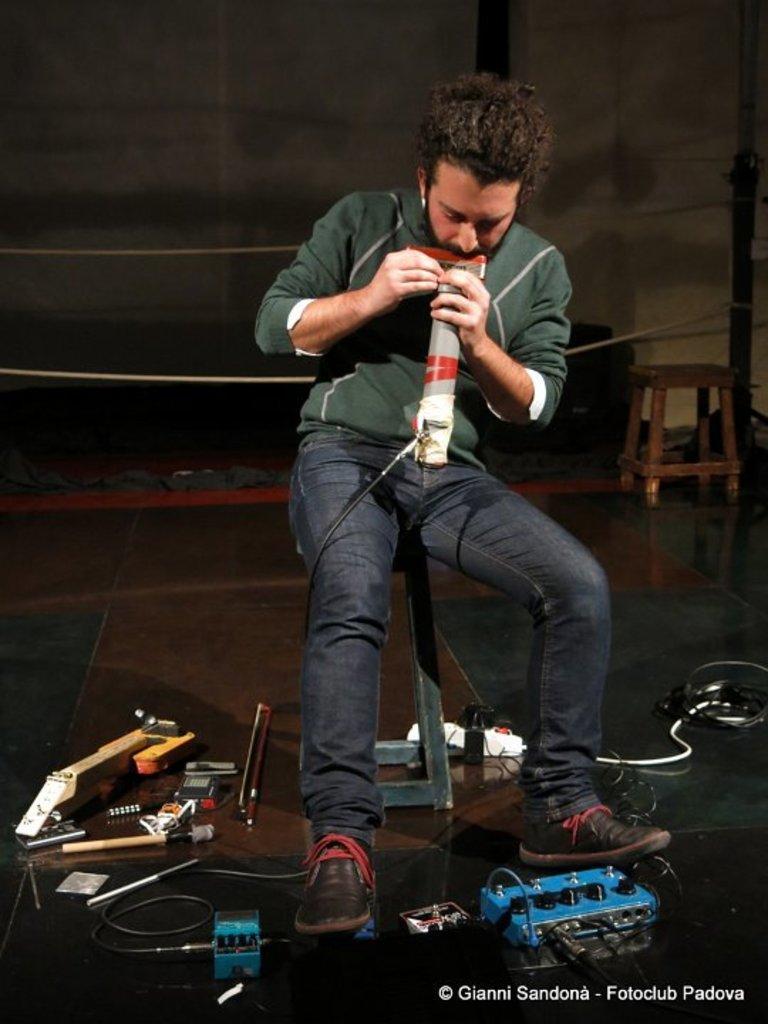Describe this image in one or two sentences. In this image, we can see a person sitting on stool and holding a gadget with his hands. There are some objects at the bottom of the image. There is an another stool on the right side of the image. 